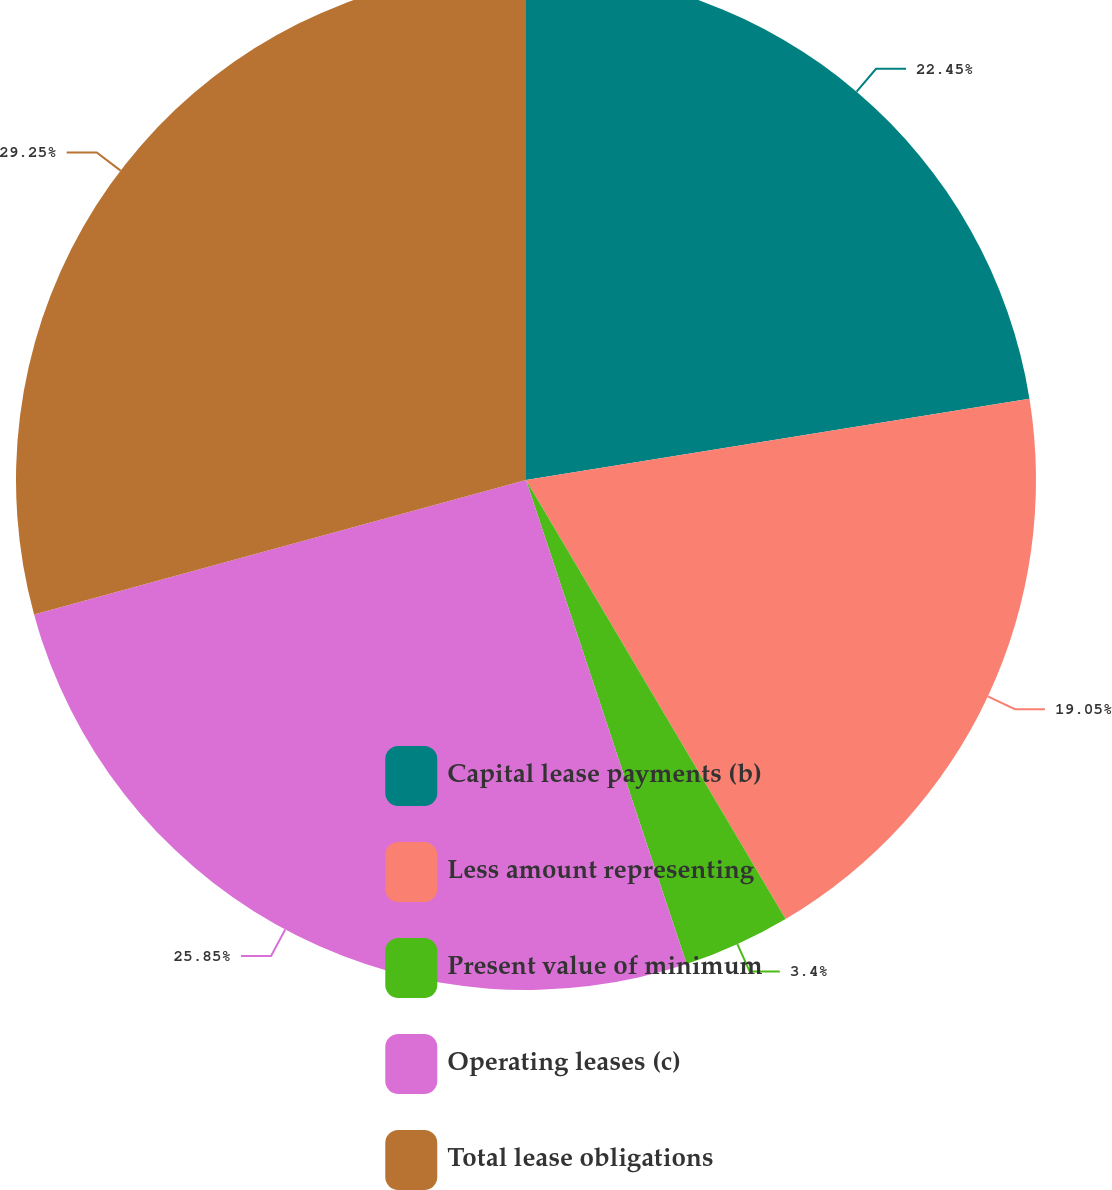Convert chart to OTSL. <chart><loc_0><loc_0><loc_500><loc_500><pie_chart><fcel>Capital lease payments (b)<fcel>Less amount representing<fcel>Present value of minimum<fcel>Operating leases (c)<fcel>Total lease obligations<nl><fcel>22.45%<fcel>19.05%<fcel>3.4%<fcel>25.85%<fcel>29.25%<nl></chart> 